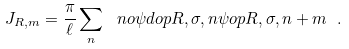<formula> <loc_0><loc_0><loc_500><loc_500>J _ { \L R , m } = \frac { \pi } { \ell } \sum _ { n } \ n o { \psi d o p { \L R , \sigma , n } \psi o p { \L R , \sigma , n + m } } \ .</formula> 